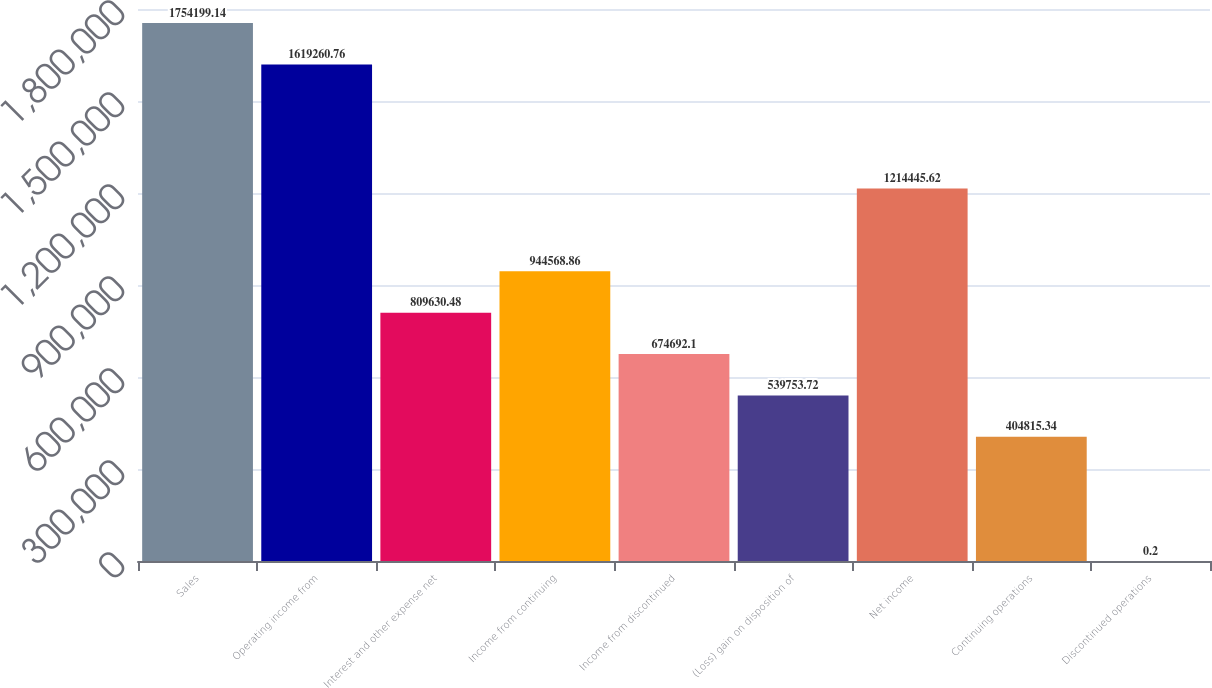Convert chart to OTSL. <chart><loc_0><loc_0><loc_500><loc_500><bar_chart><fcel>Sales<fcel>Operating income from<fcel>Interest and other expense net<fcel>Income from continuing<fcel>Income from discontinued<fcel>(Loss) gain on disposition of<fcel>Net income<fcel>Continuing operations<fcel>Discontinued operations<nl><fcel>1.7542e+06<fcel>1.61926e+06<fcel>809630<fcel>944569<fcel>674692<fcel>539754<fcel>1.21445e+06<fcel>404815<fcel>0.2<nl></chart> 